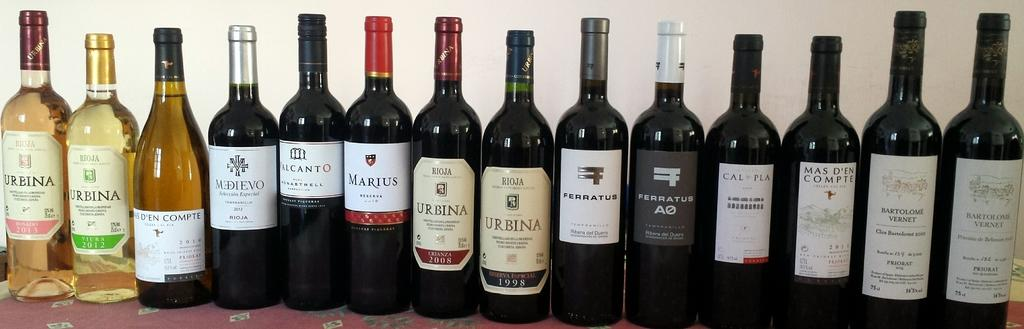<image>
Create a compact narrative representing the image presented. Several brands of wine on a table with the first one reading "URBINA". 